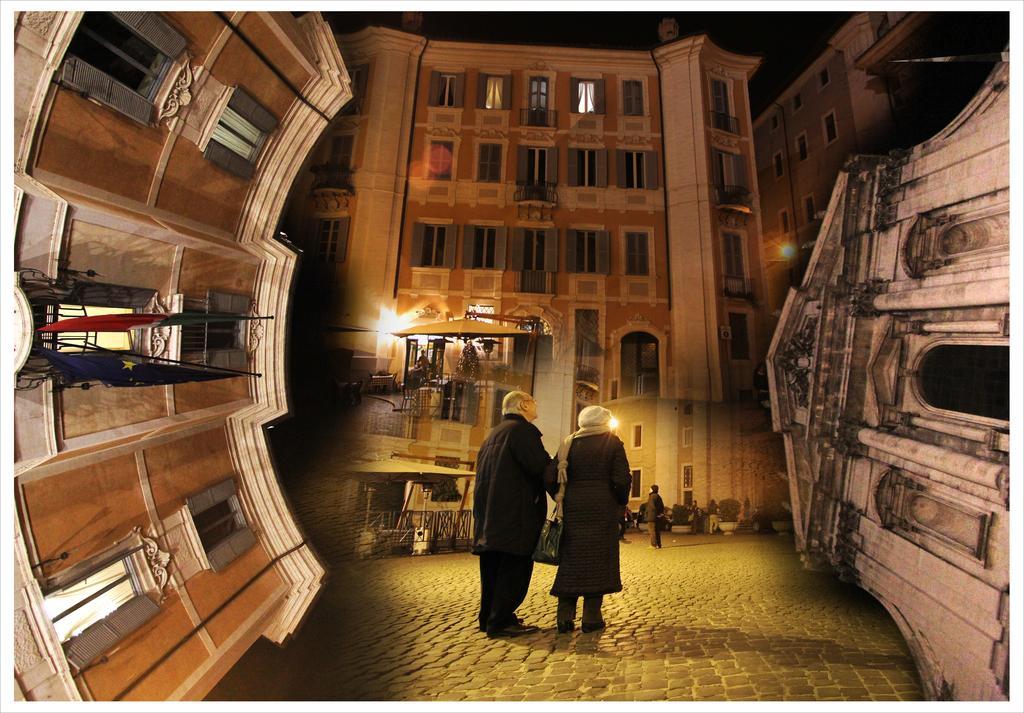Can you describe this image briefly? It is an edited image. And we can see the buildings on the left and right side of the image. On the left side building, we can see flags and windows. In the center of the image we can see two persons are standing and the right side person is holding some object. In the background, we can see buildings, windows, sheds, plant pots, plants, few people are standing and a few other objects. 